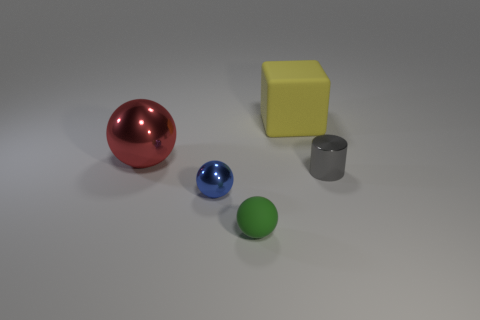Add 5 small blue matte cylinders. How many objects exist? 10 Subtract all cylinders. How many objects are left? 4 Subtract all small cyan things. Subtract all yellow objects. How many objects are left? 4 Add 4 big metallic balls. How many big metallic balls are left? 5 Add 5 small brown metal cylinders. How many small brown metal cylinders exist? 5 Subtract 0 purple cylinders. How many objects are left? 5 